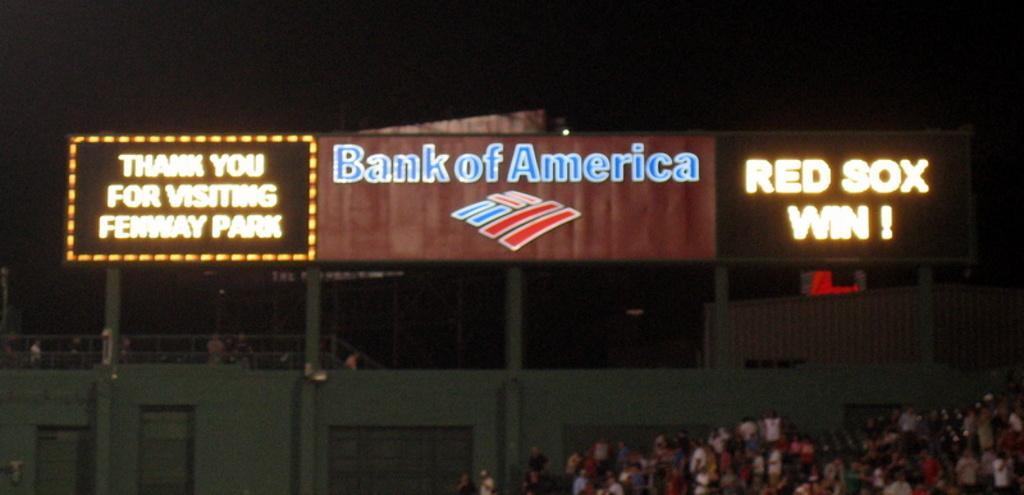In one or two sentences, can you explain what this image depicts? In this image we can see there is a building and a fence. And there are boards with text and light. And in front of the building there is a tree. 